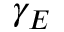Convert formula to latex. <formula><loc_0><loc_0><loc_500><loc_500>\gamma _ { E }</formula> 